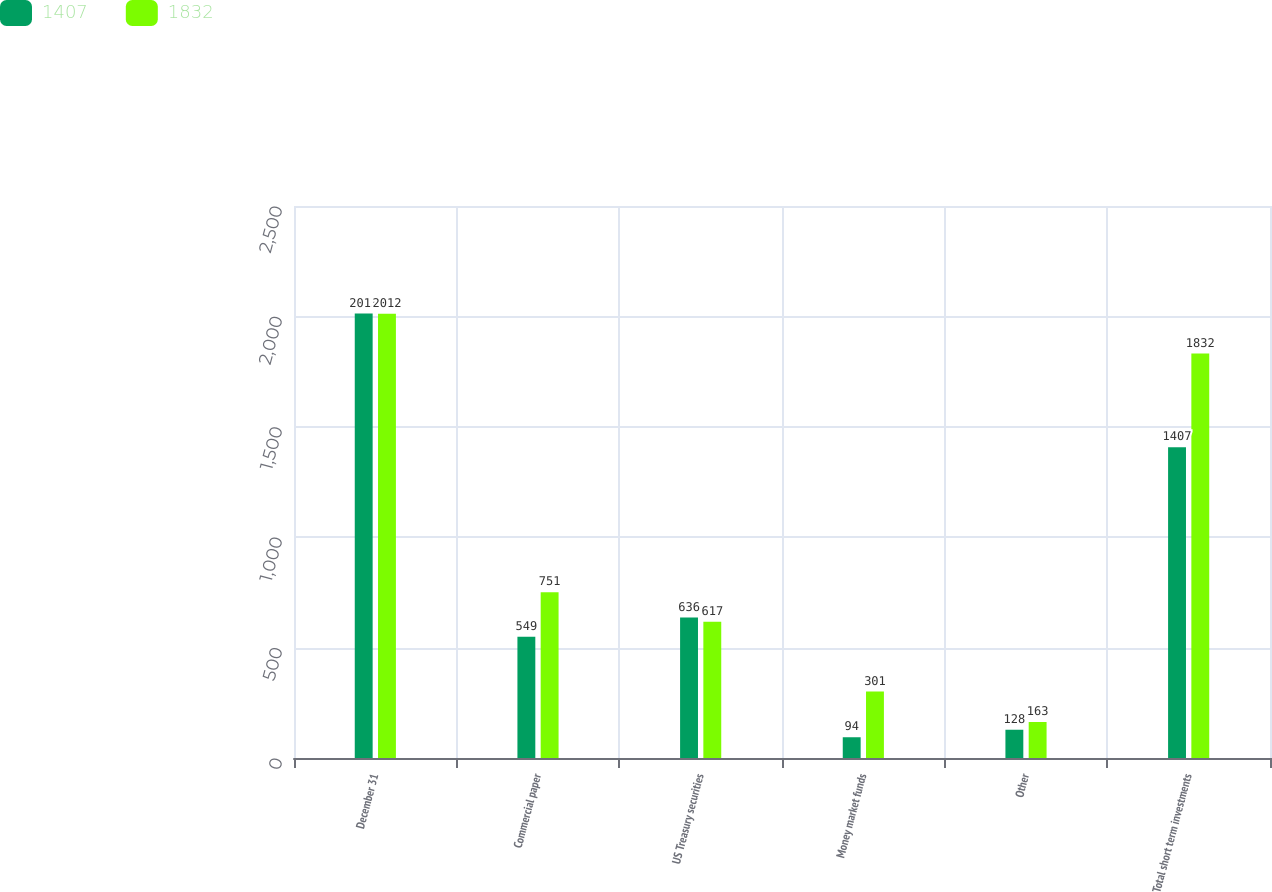Convert chart to OTSL. <chart><loc_0><loc_0><loc_500><loc_500><stacked_bar_chart><ecel><fcel>December 31<fcel>Commercial paper<fcel>US Treasury securities<fcel>Money market funds<fcel>Other<fcel>Total short term investments<nl><fcel>1407<fcel>2013<fcel>549<fcel>636<fcel>94<fcel>128<fcel>1407<nl><fcel>1832<fcel>2012<fcel>751<fcel>617<fcel>301<fcel>163<fcel>1832<nl></chart> 